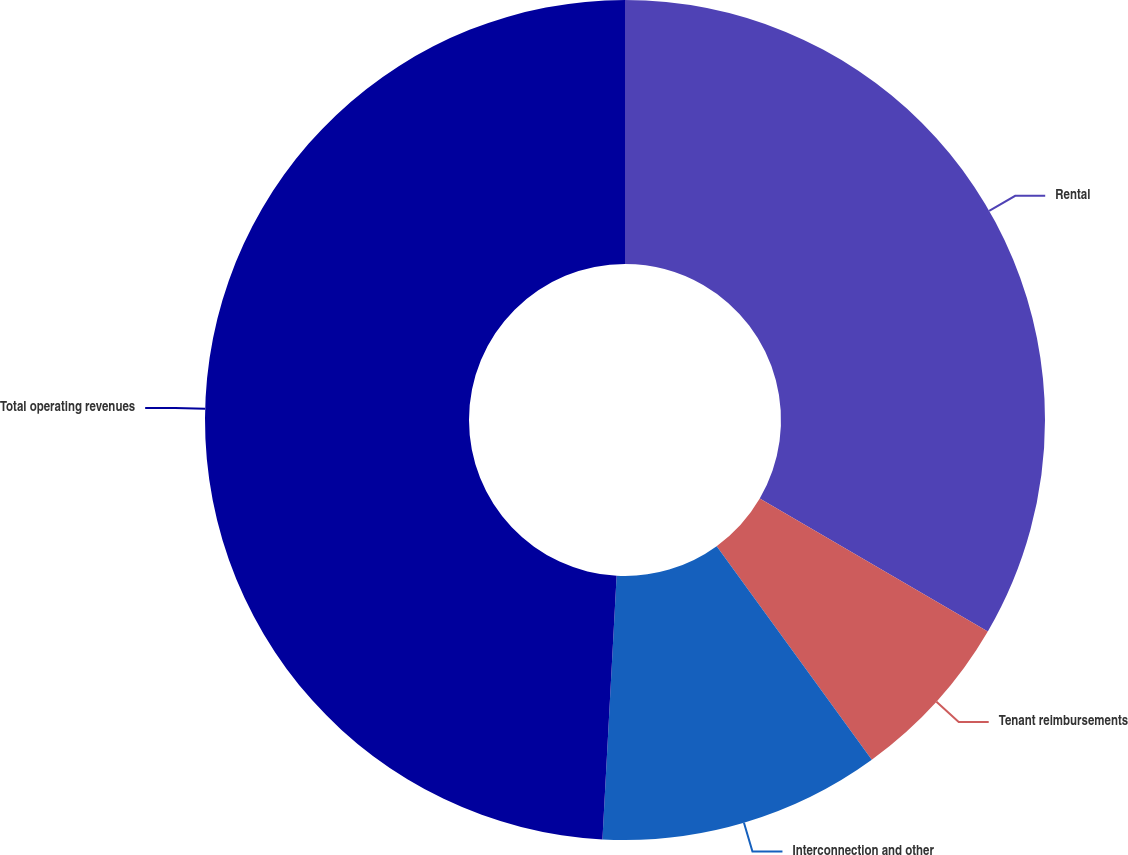<chart> <loc_0><loc_0><loc_500><loc_500><pie_chart><fcel>Rental<fcel>Tenant reimbursements<fcel>Interconnection and other<fcel>Total operating revenues<nl><fcel>33.4%<fcel>6.6%<fcel>10.85%<fcel>49.14%<nl></chart> 